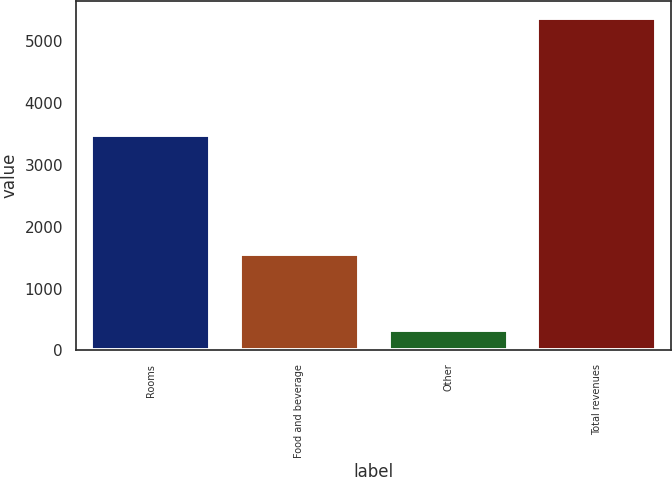<chart> <loc_0><loc_0><loc_500><loc_500><bar_chart><fcel>Rooms<fcel>Food and beverage<fcel>Other<fcel>Total revenues<nl><fcel>3490<fcel>1561<fcel>336<fcel>5387<nl></chart> 